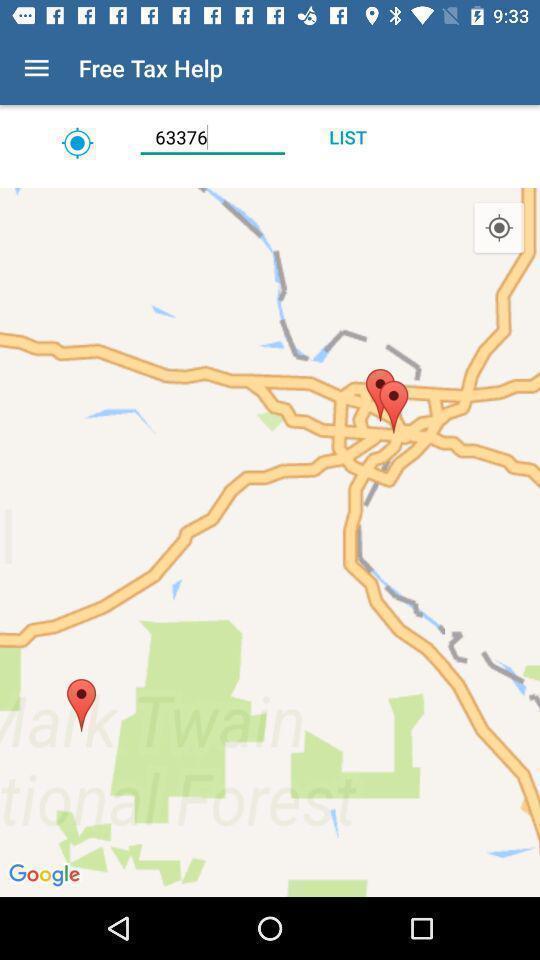Describe the key features of this screenshot. Screen showing locations. 